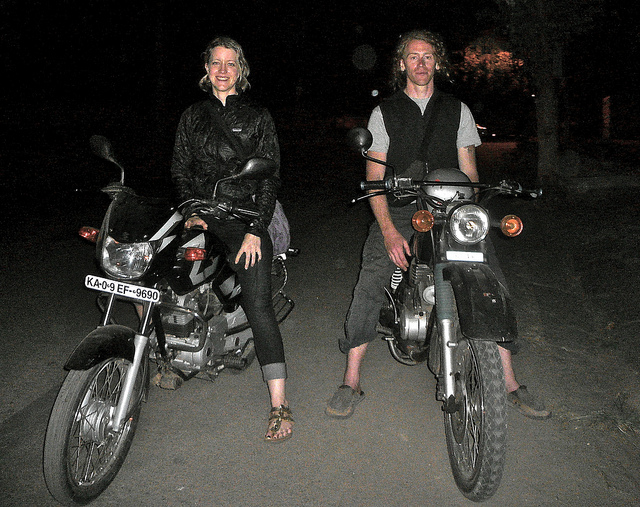How many people are in the picture? There are two people in the picture, one sitting on a motorcycle to the left and the other standing with a motorcycle to the right. 